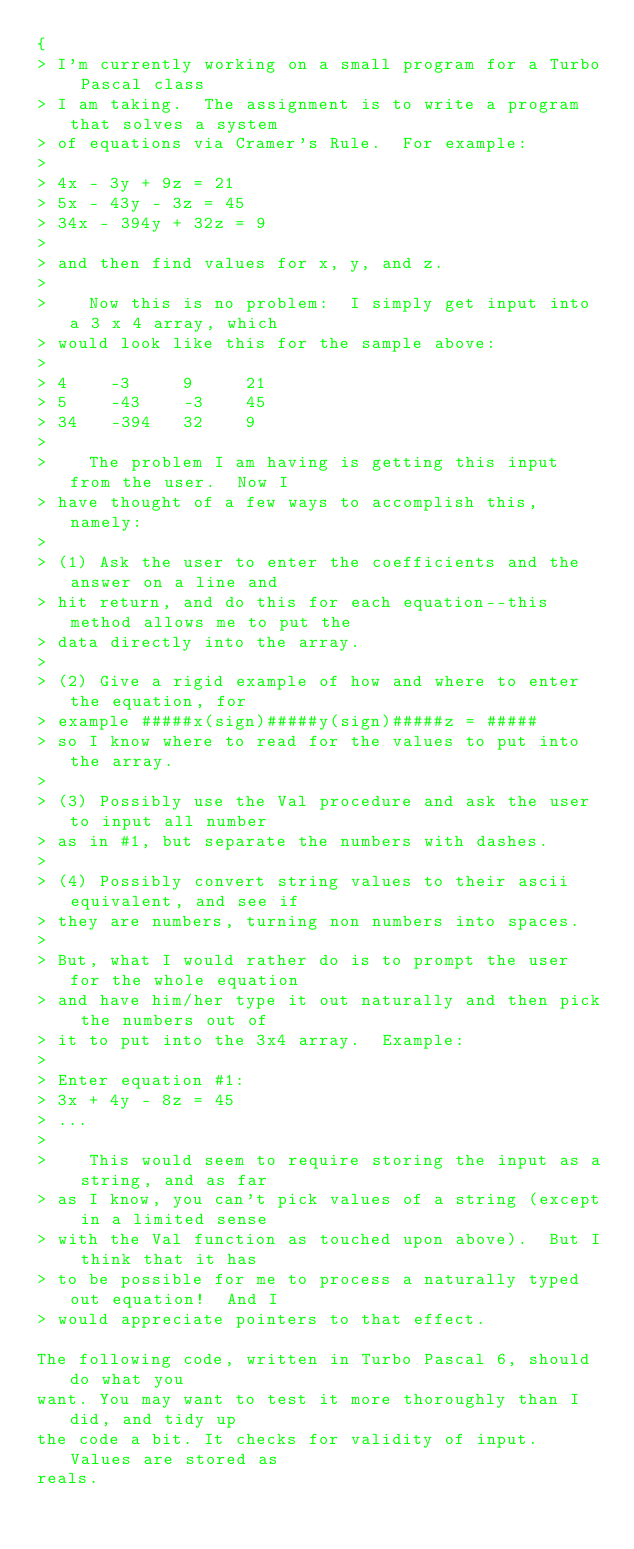Convert code to text. <code><loc_0><loc_0><loc_500><loc_500><_Pascal_>{
> I'm currently working on a small program for a Turbo Pascal class
> I am taking.  The assignment is to write a program that solves a system
> of equations via Cramer's Rule.  For example:
>
> 4x - 3y + 9z = 21
> 5x - 43y - 3z = 45
> 34x - 394y + 32z = 9
>
> and then find values for x, y, and z.
>
>    Now this is no problem:  I simply get input into a 3 x 4 array, which
> would look like this for the sample above:
>
> 4    -3     9     21
> 5    -43    -3    45
> 34   -394   32    9
>
>    The problem I am having is getting this input from the user.  Now I
> have thought of a few ways to accomplish this, namely:
>
> (1) Ask the user to enter the coefficients and the answer on a line and
> hit return, and do this for each equation--this method allows me to put the
> data directly into the array.
>
> (2) Give a rigid example of how and where to enter the equation, for
> example #####x(sign)#####y(sign)#####z = #####
> so I know where to read for the values to put into the array.
>
> (3) Possibly use the Val procedure and ask the user to input all number
> as in #1, but separate the numbers with dashes.
>
> (4) Possibly convert string values to their ascii equivalent, and see if
> they are numbers, turning non numbers into spaces.
>
> But, what I would rather do is to prompt the user for the whole equation
> and have him/her type it out naturally and then pick the numbers out of
> it to put into the 3x4 array.  Example:
>
> Enter equation #1:
> 3x + 4y - 8z = 45
> ...
>
>    This would seem to require storing the input as a string, and as far
> as I know, you can't pick values of a string (except in a limited sense
> with the Val function as touched upon above).  But I think that it has
> to be possible for me to process a naturally typed out equation!  And I
> would appreciate pointers to that effect.

The following code, written in Turbo Pascal 6, should do what you
want. You may want to test it more thoroughly than I did, and tidy up
the code a bit. It checks for validity of input. Values are stored as
reals.
</code> 